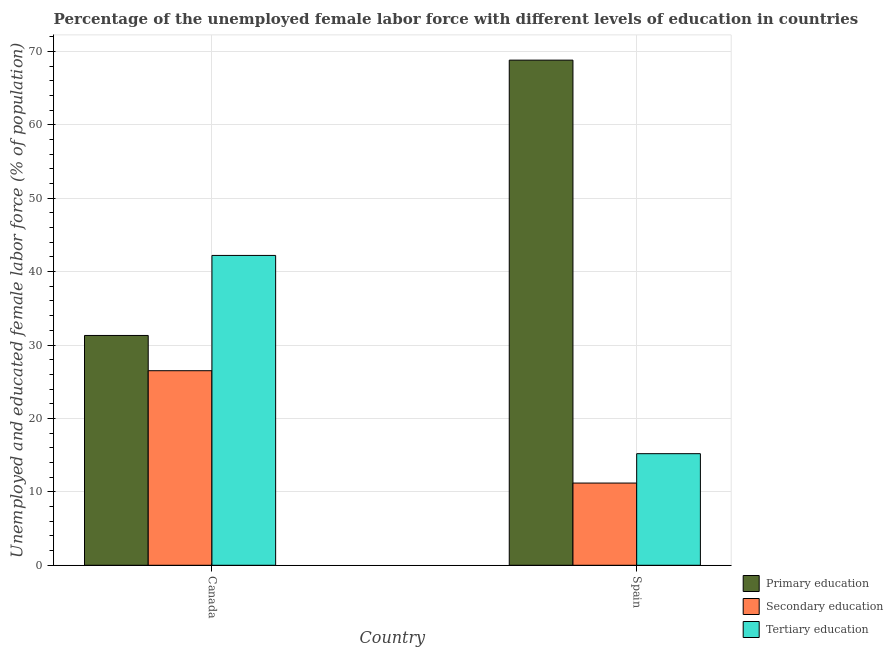How many different coloured bars are there?
Your answer should be compact. 3. Are the number of bars per tick equal to the number of legend labels?
Provide a succinct answer. Yes. How many bars are there on the 1st tick from the left?
Keep it short and to the point. 3. In how many cases, is the number of bars for a given country not equal to the number of legend labels?
Ensure brevity in your answer.  0. What is the percentage of female labor force who received secondary education in Spain?
Ensure brevity in your answer.  11.2. Across all countries, what is the maximum percentage of female labor force who received tertiary education?
Make the answer very short. 42.2. Across all countries, what is the minimum percentage of female labor force who received secondary education?
Provide a succinct answer. 11.2. In which country was the percentage of female labor force who received secondary education maximum?
Provide a succinct answer. Canada. What is the total percentage of female labor force who received secondary education in the graph?
Provide a short and direct response. 37.7. What is the difference between the percentage of female labor force who received tertiary education in Canada and that in Spain?
Provide a short and direct response. 27. What is the difference between the percentage of female labor force who received tertiary education in Canada and the percentage of female labor force who received primary education in Spain?
Offer a very short reply. -26.6. What is the average percentage of female labor force who received tertiary education per country?
Your answer should be very brief. 28.7. What is the difference between the percentage of female labor force who received secondary education and percentage of female labor force who received tertiary education in Canada?
Provide a short and direct response. -15.7. What is the ratio of the percentage of female labor force who received secondary education in Canada to that in Spain?
Keep it short and to the point. 2.37. What does the 3rd bar from the left in Spain represents?
Your answer should be compact. Tertiary education. What does the 2nd bar from the right in Spain represents?
Make the answer very short. Secondary education. Is it the case that in every country, the sum of the percentage of female labor force who received primary education and percentage of female labor force who received secondary education is greater than the percentage of female labor force who received tertiary education?
Your answer should be compact. Yes. How many bars are there?
Give a very brief answer. 6. Are all the bars in the graph horizontal?
Make the answer very short. No. What is the difference between two consecutive major ticks on the Y-axis?
Ensure brevity in your answer.  10. Are the values on the major ticks of Y-axis written in scientific E-notation?
Offer a very short reply. No. Does the graph contain grids?
Give a very brief answer. Yes. Where does the legend appear in the graph?
Give a very brief answer. Bottom right. How are the legend labels stacked?
Provide a succinct answer. Vertical. What is the title of the graph?
Make the answer very short. Percentage of the unemployed female labor force with different levels of education in countries. Does "Poland" appear as one of the legend labels in the graph?
Your response must be concise. No. What is the label or title of the X-axis?
Give a very brief answer. Country. What is the label or title of the Y-axis?
Your answer should be compact. Unemployed and educated female labor force (% of population). What is the Unemployed and educated female labor force (% of population) in Primary education in Canada?
Ensure brevity in your answer.  31.3. What is the Unemployed and educated female labor force (% of population) in Tertiary education in Canada?
Provide a succinct answer. 42.2. What is the Unemployed and educated female labor force (% of population) in Primary education in Spain?
Ensure brevity in your answer.  68.8. What is the Unemployed and educated female labor force (% of population) of Secondary education in Spain?
Offer a terse response. 11.2. What is the Unemployed and educated female labor force (% of population) of Tertiary education in Spain?
Keep it short and to the point. 15.2. Across all countries, what is the maximum Unemployed and educated female labor force (% of population) of Primary education?
Provide a short and direct response. 68.8. Across all countries, what is the maximum Unemployed and educated female labor force (% of population) of Tertiary education?
Offer a terse response. 42.2. Across all countries, what is the minimum Unemployed and educated female labor force (% of population) of Primary education?
Give a very brief answer. 31.3. Across all countries, what is the minimum Unemployed and educated female labor force (% of population) of Secondary education?
Provide a short and direct response. 11.2. Across all countries, what is the minimum Unemployed and educated female labor force (% of population) of Tertiary education?
Provide a succinct answer. 15.2. What is the total Unemployed and educated female labor force (% of population) in Primary education in the graph?
Ensure brevity in your answer.  100.1. What is the total Unemployed and educated female labor force (% of population) of Secondary education in the graph?
Make the answer very short. 37.7. What is the total Unemployed and educated female labor force (% of population) of Tertiary education in the graph?
Ensure brevity in your answer.  57.4. What is the difference between the Unemployed and educated female labor force (% of population) in Primary education in Canada and that in Spain?
Your answer should be compact. -37.5. What is the difference between the Unemployed and educated female labor force (% of population) in Tertiary education in Canada and that in Spain?
Your response must be concise. 27. What is the difference between the Unemployed and educated female labor force (% of population) in Primary education in Canada and the Unemployed and educated female labor force (% of population) in Secondary education in Spain?
Give a very brief answer. 20.1. What is the average Unemployed and educated female labor force (% of population) of Primary education per country?
Provide a succinct answer. 50.05. What is the average Unemployed and educated female labor force (% of population) of Secondary education per country?
Provide a succinct answer. 18.85. What is the average Unemployed and educated female labor force (% of population) of Tertiary education per country?
Ensure brevity in your answer.  28.7. What is the difference between the Unemployed and educated female labor force (% of population) in Primary education and Unemployed and educated female labor force (% of population) in Secondary education in Canada?
Ensure brevity in your answer.  4.8. What is the difference between the Unemployed and educated female labor force (% of population) in Primary education and Unemployed and educated female labor force (% of population) in Tertiary education in Canada?
Your answer should be compact. -10.9. What is the difference between the Unemployed and educated female labor force (% of population) of Secondary education and Unemployed and educated female labor force (% of population) of Tertiary education in Canada?
Offer a very short reply. -15.7. What is the difference between the Unemployed and educated female labor force (% of population) in Primary education and Unemployed and educated female labor force (% of population) in Secondary education in Spain?
Ensure brevity in your answer.  57.6. What is the difference between the Unemployed and educated female labor force (% of population) of Primary education and Unemployed and educated female labor force (% of population) of Tertiary education in Spain?
Provide a succinct answer. 53.6. What is the ratio of the Unemployed and educated female labor force (% of population) in Primary education in Canada to that in Spain?
Ensure brevity in your answer.  0.45. What is the ratio of the Unemployed and educated female labor force (% of population) of Secondary education in Canada to that in Spain?
Provide a succinct answer. 2.37. What is the ratio of the Unemployed and educated female labor force (% of population) of Tertiary education in Canada to that in Spain?
Your response must be concise. 2.78. What is the difference between the highest and the second highest Unemployed and educated female labor force (% of population) of Primary education?
Keep it short and to the point. 37.5. What is the difference between the highest and the second highest Unemployed and educated female labor force (% of population) in Tertiary education?
Your response must be concise. 27. What is the difference between the highest and the lowest Unemployed and educated female labor force (% of population) in Primary education?
Your answer should be compact. 37.5. 